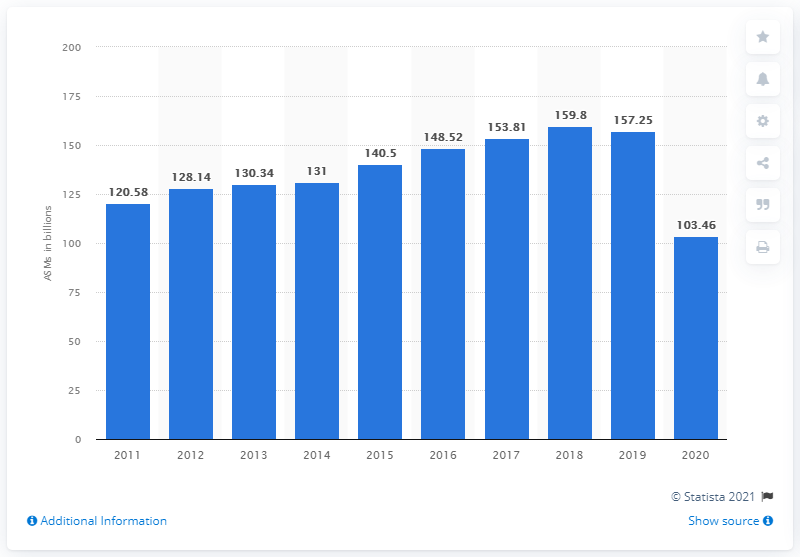Give some essential details in this illustration. Southwest Airlines' available seat miles in 2020 were 103.46. In 2011, Southwest Airlines had 120,580 available seat miles. In 2019, Southwest Airlines had a total of 157.25 available seat miles. 